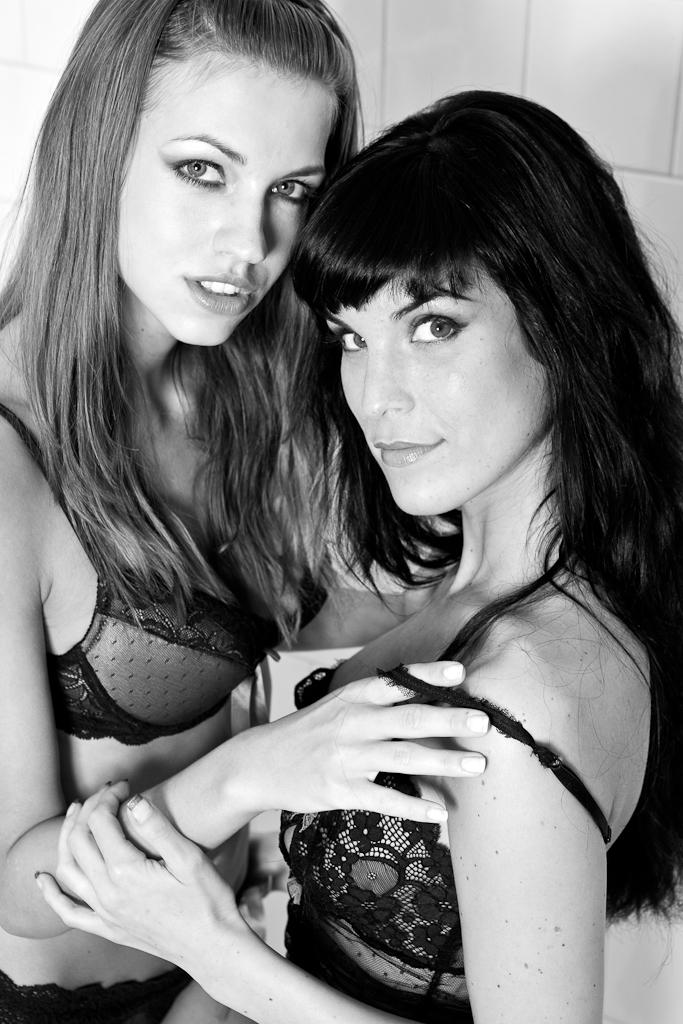How many people are present in the image? There are two people in the image. What are the people wearing? Both people are wearing dresses. What can be seen in the background of the image? There is a wall visible in the background of the image. What is the color scheme of the image? The image is black and white. How many clocks are visible on the wall in the image? There are no clocks visible on the wall in the image. What day of the week is depicted in the image? The image does not depict a specific day of the week, as it is a black and white photograph. 